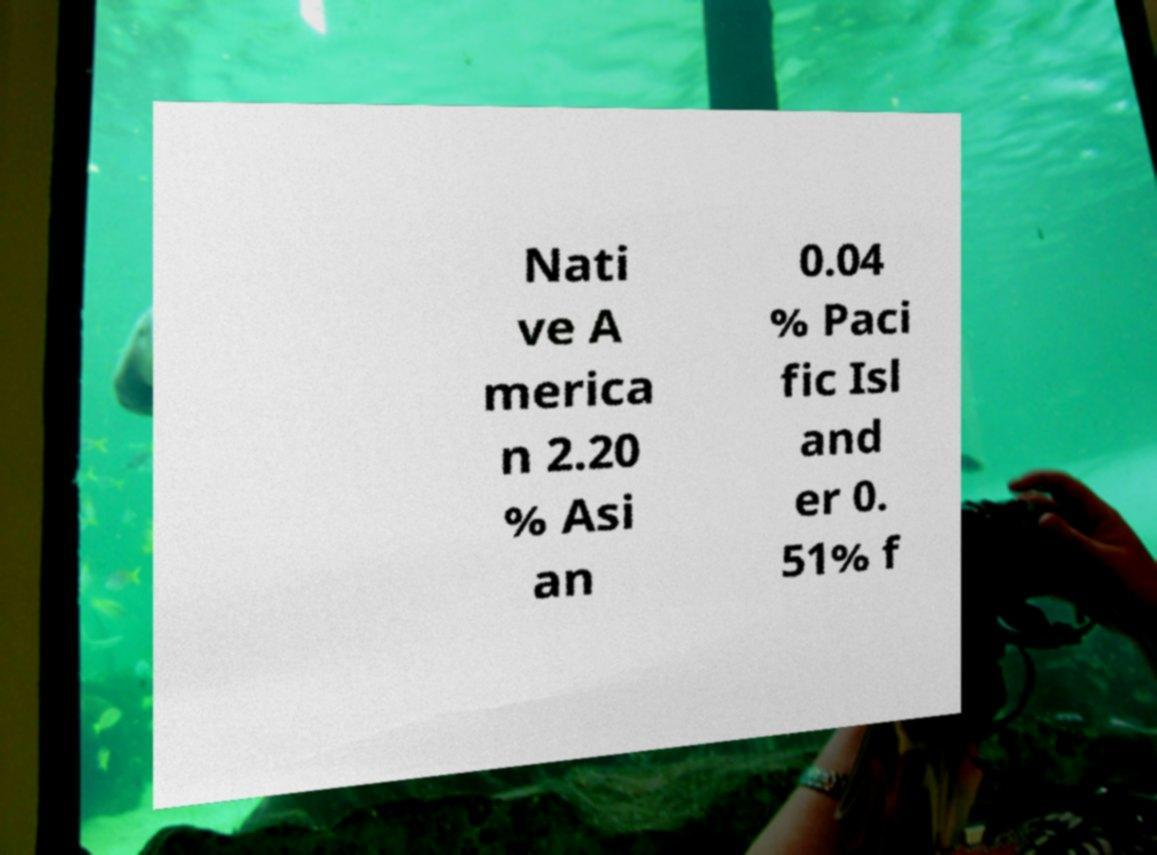Please read and relay the text visible in this image. What does it say? Nati ve A merica n 2.20 % Asi an 0.04 % Paci fic Isl and er 0. 51% f 